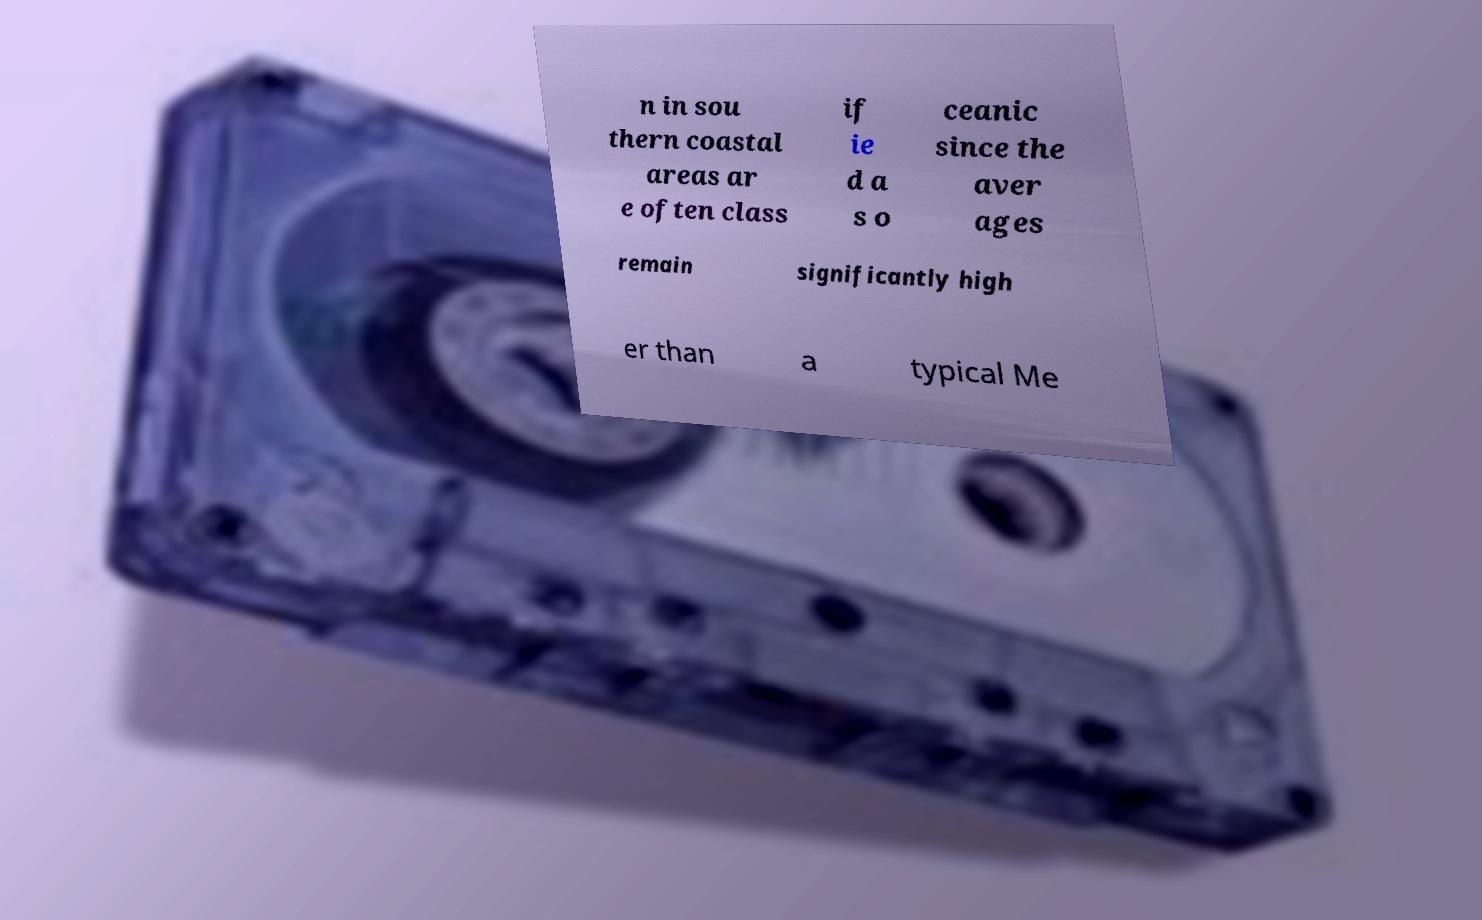Please read and relay the text visible in this image. What does it say? n in sou thern coastal areas ar e often class if ie d a s o ceanic since the aver ages remain significantly high er than a typical Me 